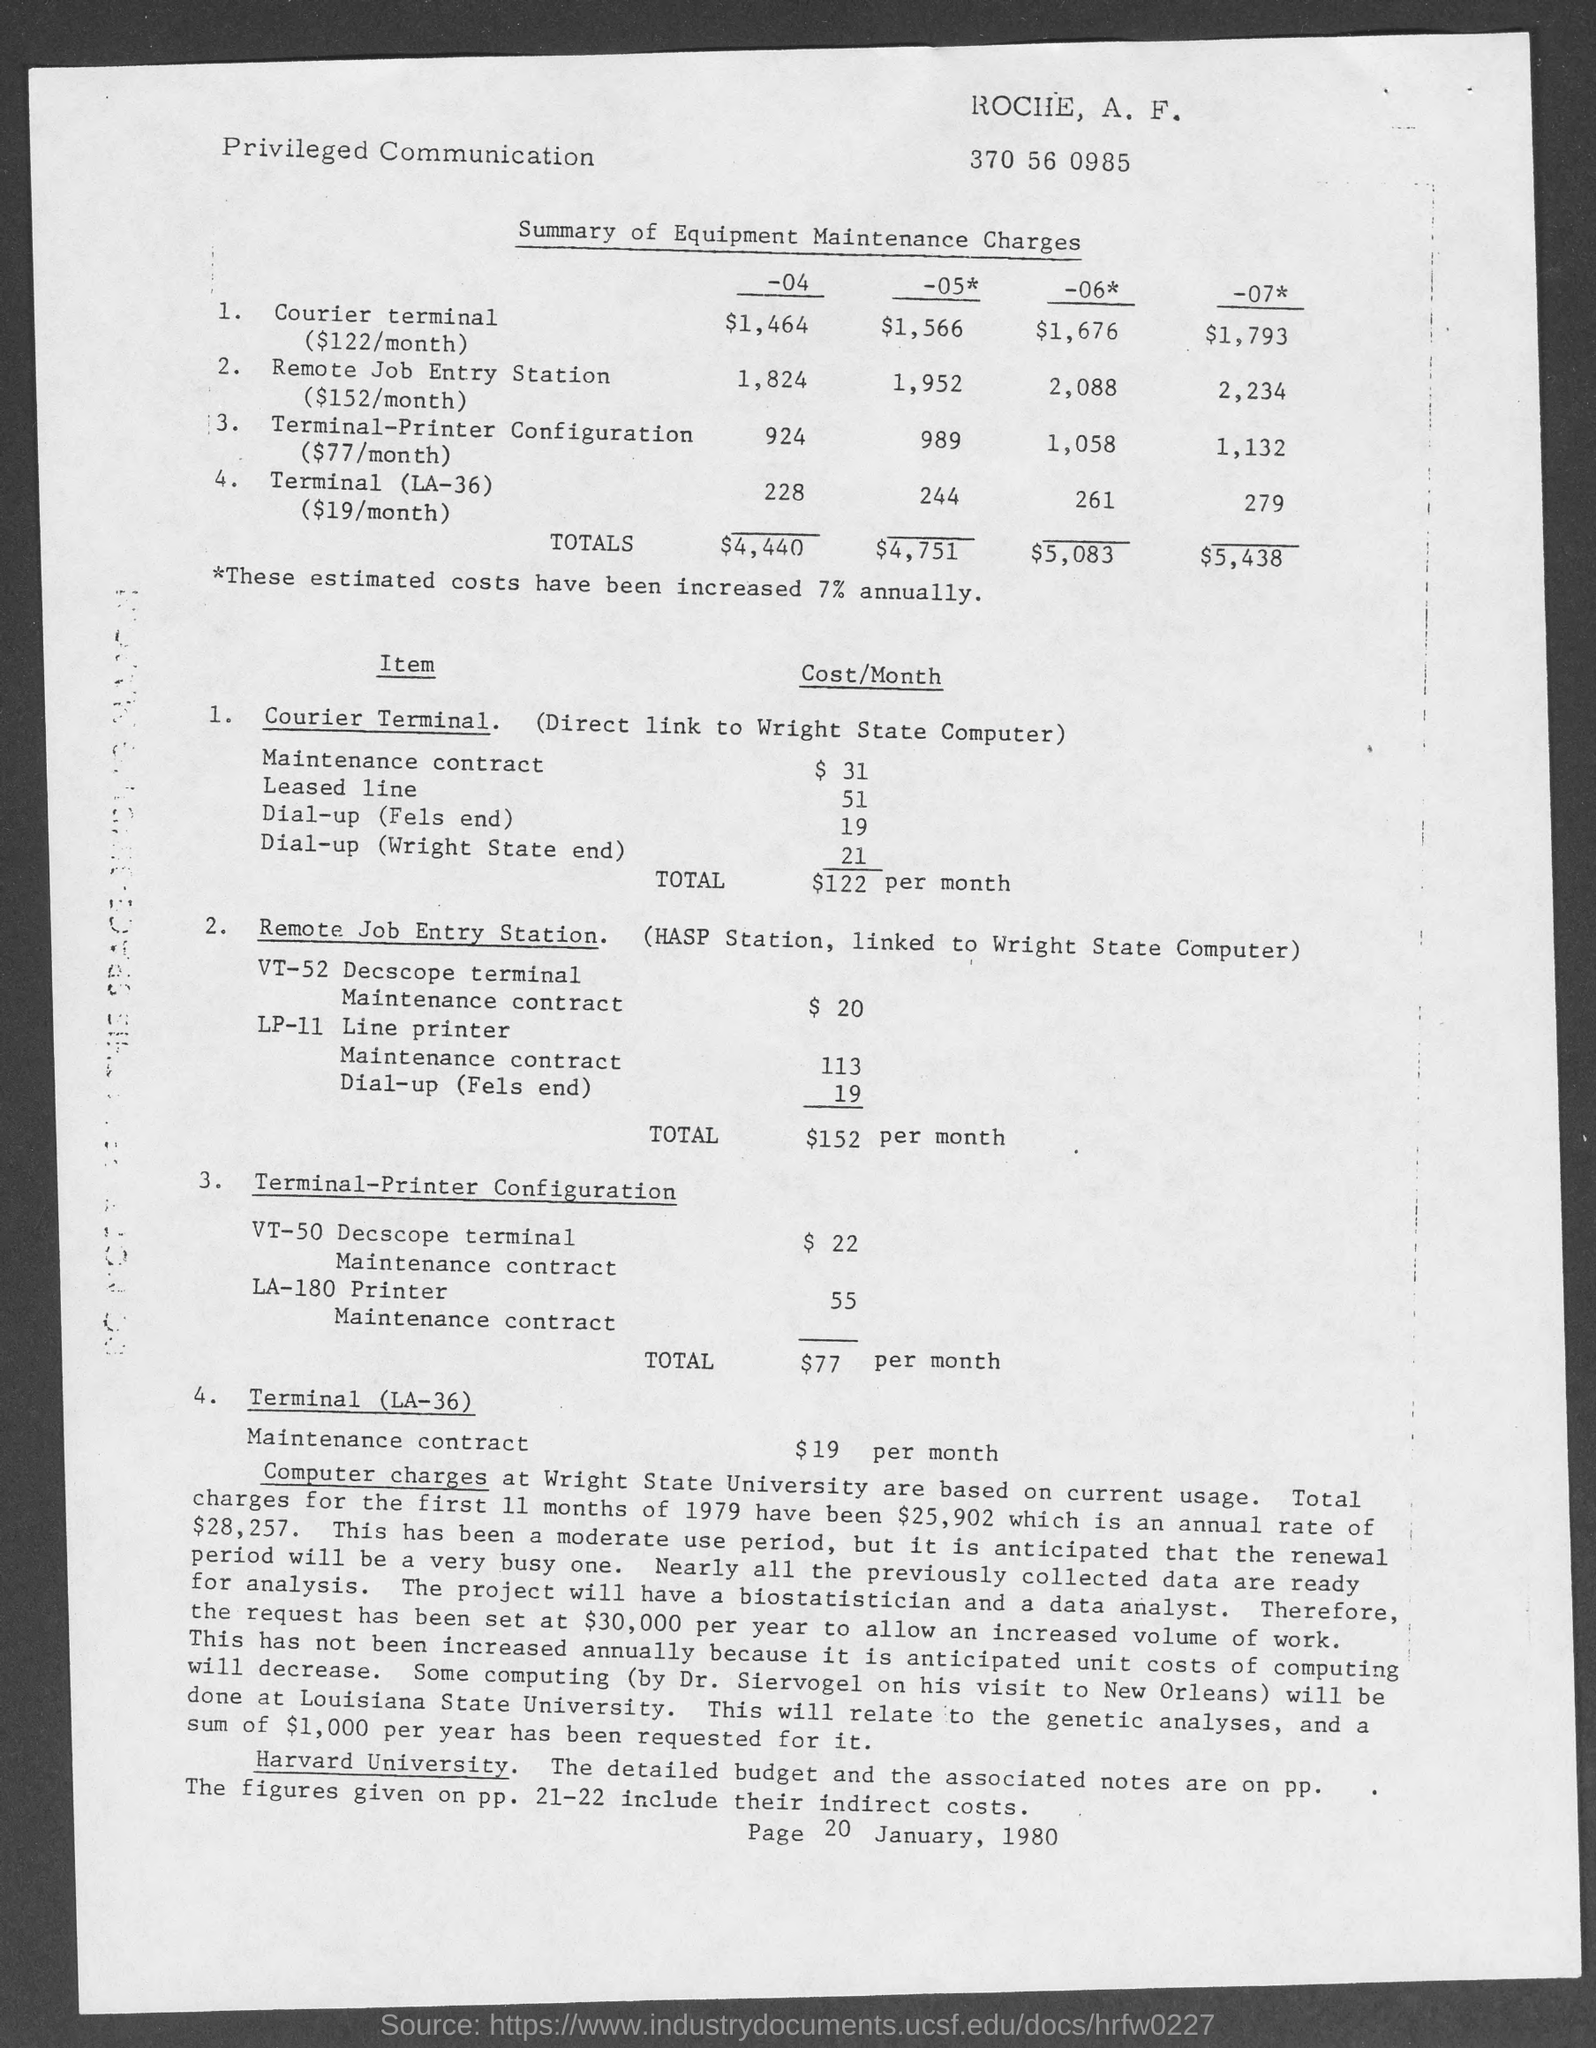Identify some key points in this picture. The total cost of "Terminal-(LA-36)" per month is $19. Please mention the page number provided at the end of the page, which is page 20. The monthly cost for maintaining the VT-52 Decscope terminal with a Remote Job Entry Station is $20. This type of communication is privileged, which means it is confidential and not intended for third-party disclosure. The total cost of the Remote Job Entry Station per month is $152. 